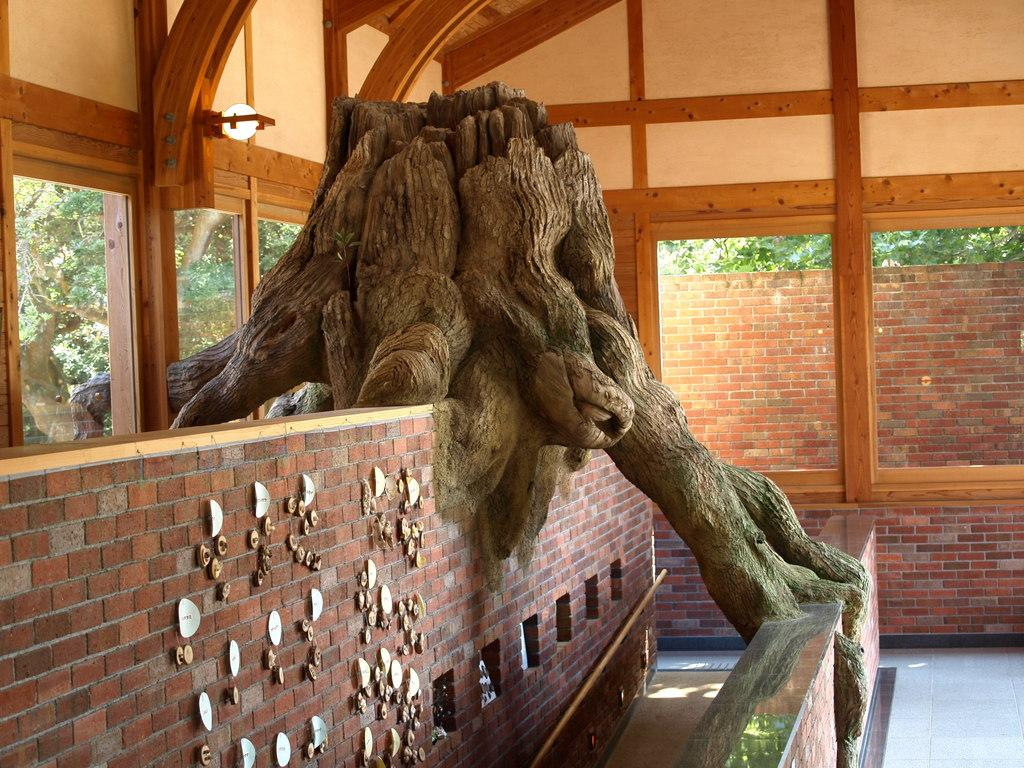What type of walls are present in the image? There are brick walls in the image. What can be seen in the image besides the brick walls? There is a tree trunk and windows visible in the image. What is located behind the windows in the image? Trees are visible behind the windows in the image. Where is the lunchroom located in the image? There is no mention of a lunchroom in the image; it only features brick walls, a tree trunk, windows, and trees behind the windows. 